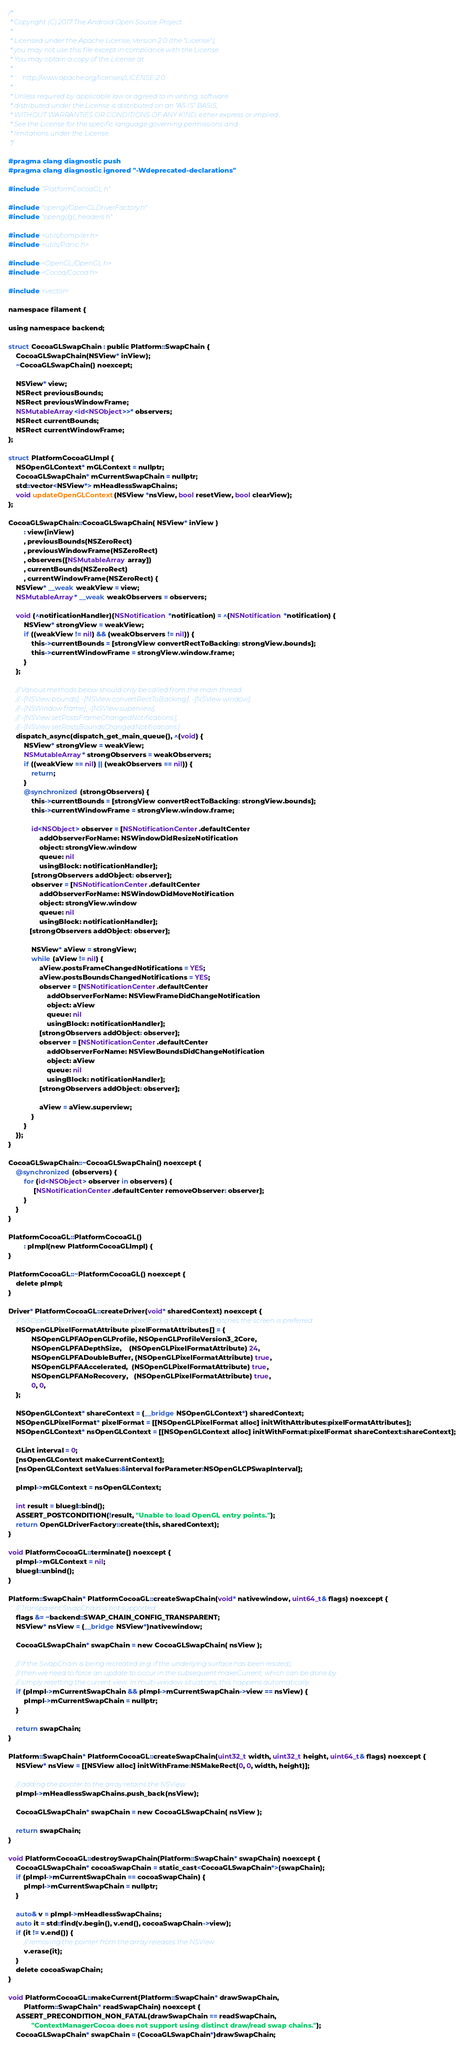Convert code to text. <code><loc_0><loc_0><loc_500><loc_500><_ObjectiveC_>/*
 * Copyright (C) 2017 The Android Open Source Project
 *
 * Licensed under the Apache License, Version 2.0 (the "License");
 * you may not use this file except in compliance with the License.
 * You may obtain a copy of the License at
 *
 *      http://www.apache.org/licenses/LICENSE-2.0
 *
 * Unless required by applicable law or agreed to in writing, software
 * distributed under the License is distributed on an "AS IS" BASIS,
 * WITHOUT WARRANTIES OR CONDITIONS OF ANY KIND, either express or implied.
 * See the License for the specific language governing permissions and
 * limitations under the License.
 */

#pragma clang diagnostic push
#pragma clang diagnostic ignored "-Wdeprecated-declarations"

#include "PlatformCocoaGL.h"

#include "opengl/OpenGLDriverFactory.h"
#include "opengl/gl_headers.h"

#include <utils/compiler.h>
#include <utils/Panic.h>

#include <OpenGL/OpenGL.h>
#include <Cocoa/Cocoa.h>

#include <vector>

namespace filament {

using namespace backend;

struct CocoaGLSwapChain : public Platform::SwapChain {
    CocoaGLSwapChain(NSView* inView);
    ~CocoaGLSwapChain() noexcept;

    NSView* view;
    NSRect previousBounds;
    NSRect previousWindowFrame;
    NSMutableArray<id<NSObject>>* observers;
    NSRect currentBounds;
    NSRect currentWindowFrame;
};

struct PlatformCocoaGLImpl {
    NSOpenGLContext* mGLContext = nullptr;
    CocoaGLSwapChain* mCurrentSwapChain = nullptr;
    std::vector<NSView*> mHeadlessSwapChains;
    void updateOpenGLContext(NSView *nsView, bool resetView, bool clearView);
};

CocoaGLSwapChain::CocoaGLSwapChain( NSView* inView )
        : view(inView)
        , previousBounds(NSZeroRect)
        , previousWindowFrame(NSZeroRect)
        , observers([NSMutableArray array])
        , currentBounds(NSZeroRect)
        , currentWindowFrame(NSZeroRect) {
    NSView* __weak weakView = view;
    NSMutableArray* __weak weakObservers = observers;
    
    void (^notificationHandler)(NSNotification *notification) = ^(NSNotification *notification) {
        NSView* strongView = weakView;
        if ((weakView != nil) && (weakObservers != nil)) {
            this->currentBounds = [strongView convertRectToBacking: strongView.bounds];
            this->currentWindowFrame = strongView.window.frame;
        }
    };
    
    // Various methods below should only be called from the main thread:
    // -[NSView bounds], -[NSView convertRectToBacking:], -[NSView window],
    // -[NSWindow frame], -[NSView superview],
    // -[NSView setPostsFrameChangedNotifications:],
    // -[NSView setPostsBoundsChangedNotifications:]
    dispatch_async(dispatch_get_main_queue(), ^(void) {
        NSView* strongView = weakView;
        NSMutableArray* strongObservers = weakObservers;
        if ((weakView == nil) || (weakObservers == nil)) {
            return;
        }
        @synchronized (strongObservers) {
            this->currentBounds = [strongView convertRectToBacking: strongView.bounds];
            this->currentWindowFrame = strongView.window.frame;

            id<NSObject> observer = [NSNotificationCenter.defaultCenter
                addObserverForName: NSWindowDidResizeNotification
                object: strongView.window
                queue: nil
                usingBlock: notificationHandler];
            [strongObservers addObject: observer];
            observer = [NSNotificationCenter.defaultCenter
                addObserverForName: NSWindowDidMoveNotification
                object: strongView.window
                queue: nil
                usingBlock: notificationHandler];
           [strongObservers addObject: observer];

            NSView* aView = strongView;
            while (aView != nil) {
                aView.postsFrameChangedNotifications = YES;
                aView.postsBoundsChangedNotifications = YES;
                observer = [NSNotificationCenter.defaultCenter
                    addObserverForName: NSViewFrameDidChangeNotification
                    object: aView
                    queue: nil
                    usingBlock: notificationHandler];
                [strongObservers addObject: observer];
                observer = [NSNotificationCenter.defaultCenter
                    addObserverForName: NSViewBoundsDidChangeNotification
                    object: aView
                    queue: nil
                    usingBlock: notificationHandler];
                [strongObservers addObject: observer];
                
                aView = aView.superview;
            }
        }
    });
}

CocoaGLSwapChain::~CocoaGLSwapChain() noexcept {
    @synchronized (observers) {
        for (id<NSObject> observer in observers) {
             [NSNotificationCenter.defaultCenter removeObserver: observer];
        }
    }
}

PlatformCocoaGL::PlatformCocoaGL()
        : pImpl(new PlatformCocoaGLImpl) {
}

PlatformCocoaGL::~PlatformCocoaGL() noexcept {
    delete pImpl;
}

Driver* PlatformCocoaGL::createDriver(void* sharedContext) noexcept {
    // NSOpenGLPFAColorSize: when unspecified, a format that matches the screen is preferred
    NSOpenGLPixelFormatAttribute pixelFormatAttributes[] = {
            NSOpenGLPFAOpenGLProfile, NSOpenGLProfileVersion3_2Core,
            NSOpenGLPFADepthSize,    (NSOpenGLPixelFormatAttribute) 24,
            NSOpenGLPFADoubleBuffer, (NSOpenGLPixelFormatAttribute) true,
            NSOpenGLPFAAccelerated,  (NSOpenGLPixelFormatAttribute) true,
            NSOpenGLPFANoRecovery,   (NSOpenGLPixelFormatAttribute) true,
            0, 0,
    };

    NSOpenGLContext* shareContext = (__bridge NSOpenGLContext*) sharedContext;
    NSOpenGLPixelFormat* pixelFormat = [[NSOpenGLPixelFormat alloc] initWithAttributes:pixelFormatAttributes];
    NSOpenGLContext* nsOpenGLContext = [[NSOpenGLContext alloc] initWithFormat:pixelFormat shareContext:shareContext];

    GLint interval = 0;
    [nsOpenGLContext makeCurrentContext];
    [nsOpenGLContext setValues:&interval forParameter:NSOpenGLCPSwapInterval];

    pImpl->mGLContext = nsOpenGLContext;

    int result = bluegl::bind();
    ASSERT_POSTCONDITION(!result, "Unable to load OpenGL entry points.");
    return OpenGLDriverFactory::create(this, sharedContext);
}

void PlatformCocoaGL::terminate() noexcept {
    pImpl->mGLContext = nil;
    bluegl::unbind();
}

Platform::SwapChain* PlatformCocoaGL::createSwapChain(void* nativewindow, uint64_t& flags) noexcept {
    // Transparent SwapChain is not supported
    flags &= ~backend::SWAP_CHAIN_CONFIG_TRANSPARENT;
    NSView* nsView = (__bridge NSView*)nativewindow;

    CocoaGLSwapChain* swapChain = new CocoaGLSwapChain( nsView );

    // If the SwapChain is being recreated (e.g. if the underlying surface has been resized),
    // then we need to force an update to occur in the subsequent makeCurrent, which can be done by
    // simply resetting the current view. In multi-window situations, this happens automatically.
    if (pImpl->mCurrentSwapChain && pImpl->mCurrentSwapChain->view == nsView) {
        pImpl->mCurrentSwapChain = nullptr;
    }

    return swapChain;
}

Platform::SwapChain* PlatformCocoaGL::createSwapChain(uint32_t width, uint32_t height, uint64_t& flags) noexcept {
    NSView* nsView = [[NSView alloc] initWithFrame:NSMakeRect(0, 0, width, height)];

    // adding the pointer to the array retains the NSView
    pImpl->mHeadlessSwapChains.push_back(nsView);

    CocoaGLSwapChain* swapChain = new CocoaGLSwapChain( nsView );

    return swapChain;
}

void PlatformCocoaGL::destroySwapChain(Platform::SwapChain* swapChain) noexcept {
    CocoaGLSwapChain* cocoaSwapChain = static_cast<CocoaGLSwapChain*>(swapChain);
    if (pImpl->mCurrentSwapChain == cocoaSwapChain) {
        pImpl->mCurrentSwapChain = nullptr;
    }

    auto& v = pImpl->mHeadlessSwapChains;
    auto it = std::find(v.begin(), v.end(), cocoaSwapChain->view);
    if (it != v.end()) {
        // removing the pointer from the array releases the NSView
        v.erase(it);
    }
    delete cocoaSwapChain;
}

void PlatformCocoaGL::makeCurrent(Platform::SwapChain* drawSwapChain,
        Platform::SwapChain* readSwapChain) noexcept {
    ASSERT_PRECONDITION_NON_FATAL(drawSwapChain == readSwapChain,
            "ContextManagerCocoa does not support using distinct draw/read swap chains.");
    CocoaGLSwapChain* swapChain = (CocoaGLSwapChain*)drawSwapChain;</code> 